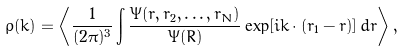Convert formula to latex. <formula><loc_0><loc_0><loc_500><loc_500>\rho ( { k } ) = \left < \frac { 1 } { ( 2 \pi ) ^ { 3 } } \int \frac { \Psi ( { r } , { r } _ { 2 } , \dots , { r } _ { N } ) } { \Psi ( { R } ) } \exp [ i { k } \cdot ( { r } _ { 1 } - { r } ) ] \, d { r } \right > ,</formula> 